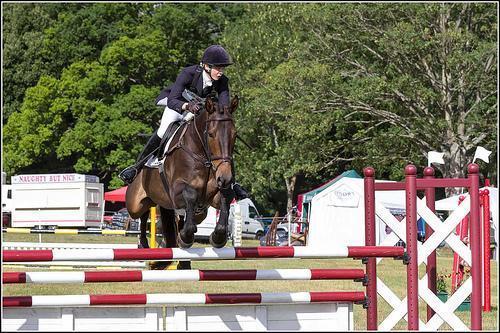How many people are in the picture?
Give a very brief answer. 1. 